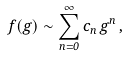<formula> <loc_0><loc_0><loc_500><loc_500>f ( g ) \sim \sum _ { n = 0 } ^ { \infty } c _ { n } \, g ^ { n } \, ,</formula> 